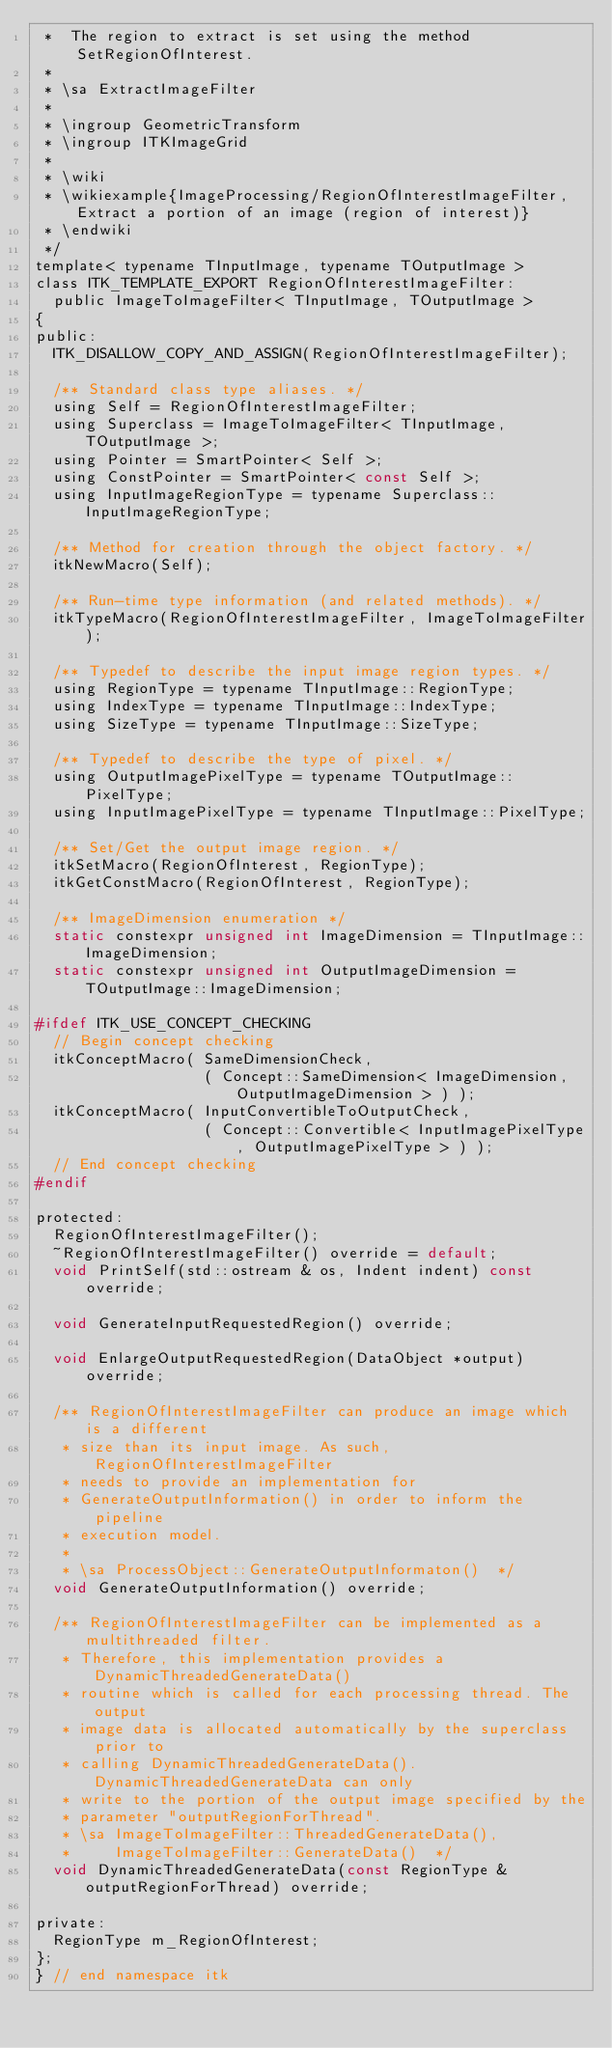<code> <loc_0><loc_0><loc_500><loc_500><_C_> *  The region to extract is set using the method SetRegionOfInterest.
 *
 * \sa ExtractImageFilter
 *
 * \ingroup GeometricTransform
 * \ingroup ITKImageGrid
 *
 * \wiki
 * \wikiexample{ImageProcessing/RegionOfInterestImageFilter,Extract a portion of an image (region of interest)}
 * \endwiki
 */
template< typename TInputImage, typename TOutputImage >
class ITK_TEMPLATE_EXPORT RegionOfInterestImageFilter:
  public ImageToImageFilter< TInputImage, TOutputImage >
{
public:
  ITK_DISALLOW_COPY_AND_ASSIGN(RegionOfInterestImageFilter);

  /** Standard class type aliases. */
  using Self = RegionOfInterestImageFilter;
  using Superclass = ImageToImageFilter< TInputImage, TOutputImage >;
  using Pointer = SmartPointer< Self >;
  using ConstPointer = SmartPointer< const Self >;
  using InputImageRegionType = typename Superclass::InputImageRegionType;

  /** Method for creation through the object factory. */
  itkNewMacro(Self);

  /** Run-time type information (and related methods). */
  itkTypeMacro(RegionOfInterestImageFilter, ImageToImageFilter);

  /** Typedef to describe the input image region types. */
  using RegionType = typename TInputImage::RegionType;
  using IndexType = typename TInputImage::IndexType;
  using SizeType = typename TInputImage::SizeType;

  /** Typedef to describe the type of pixel. */
  using OutputImagePixelType = typename TOutputImage::PixelType;
  using InputImagePixelType = typename TInputImage::PixelType;

  /** Set/Get the output image region. */
  itkSetMacro(RegionOfInterest, RegionType);
  itkGetConstMacro(RegionOfInterest, RegionType);

  /** ImageDimension enumeration */
  static constexpr unsigned int ImageDimension = TInputImage::ImageDimension;
  static constexpr unsigned int OutputImageDimension = TOutputImage::ImageDimension;

#ifdef ITK_USE_CONCEPT_CHECKING
  // Begin concept checking
  itkConceptMacro( SameDimensionCheck,
                   ( Concept::SameDimension< ImageDimension, OutputImageDimension > ) );
  itkConceptMacro( InputConvertibleToOutputCheck,
                   ( Concept::Convertible< InputImagePixelType, OutputImagePixelType > ) );
  // End concept checking
#endif

protected:
  RegionOfInterestImageFilter();
  ~RegionOfInterestImageFilter() override = default;
  void PrintSelf(std::ostream & os, Indent indent) const override;

  void GenerateInputRequestedRegion() override;

  void EnlargeOutputRequestedRegion(DataObject *output) override;

  /** RegionOfInterestImageFilter can produce an image which is a different
   * size than its input image. As such, RegionOfInterestImageFilter
   * needs to provide an implementation for
   * GenerateOutputInformation() in order to inform the pipeline
   * execution model.
   *
   * \sa ProcessObject::GenerateOutputInformaton()  */
  void GenerateOutputInformation() override;

  /** RegionOfInterestImageFilter can be implemented as a multithreaded filter.
   * Therefore, this implementation provides a DynamicThreadedGenerateData()
   * routine which is called for each processing thread. The output
   * image data is allocated automatically by the superclass prior to
   * calling DynamicThreadedGenerateData(). DynamicThreadedGenerateData can only
   * write to the portion of the output image specified by the
   * parameter "outputRegionForThread".
   * \sa ImageToImageFilter::ThreadedGenerateData(),
   *     ImageToImageFilter::GenerateData()  */
  void DynamicThreadedGenerateData(const RegionType & outputRegionForThread) override;

private:
  RegionType m_RegionOfInterest;
};
} // end namespace itk
</code> 